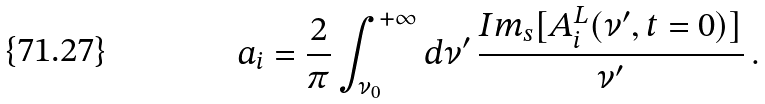<formula> <loc_0><loc_0><loc_500><loc_500>a _ { i } = \frac { 2 } { \pi } \int _ { \nu _ { 0 } } ^ { + \infty } d \nu ^ { \prime } \, \frac { I m _ { s } [ A ^ { L } _ { i } ( \nu ^ { \prime } , t = 0 ) ] } { \nu ^ { \prime } } \, .</formula> 